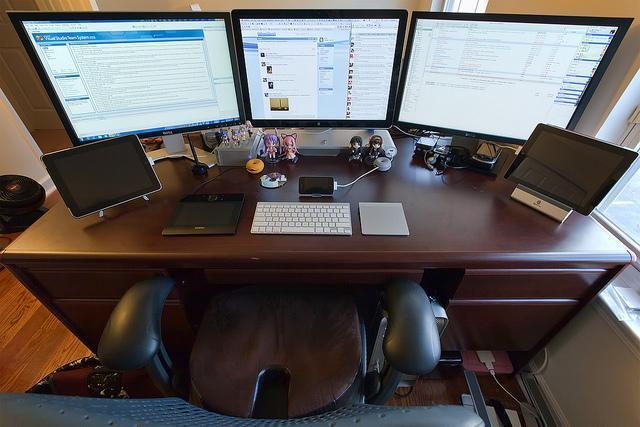How many monitors are being used?
Give a very brief answer. 3. How many tvs are there?
Give a very brief answer. 3. How many bananas are there?
Give a very brief answer. 0. 